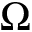Convert formula to latex. <formula><loc_0><loc_0><loc_500><loc_500>\Omega</formula> 